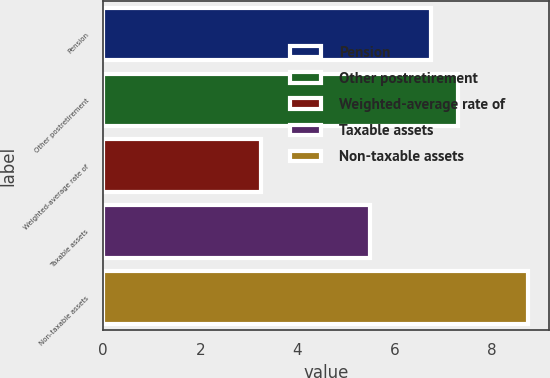Convert chart to OTSL. <chart><loc_0><loc_0><loc_500><loc_500><bar_chart><fcel>Pension<fcel>Other postretirement<fcel>Weighted-average rate of<fcel>Taxable assets<fcel>Non-taxable assets<nl><fcel>6.75<fcel>7.3<fcel>3.25<fcel>5.5<fcel>8.75<nl></chart> 